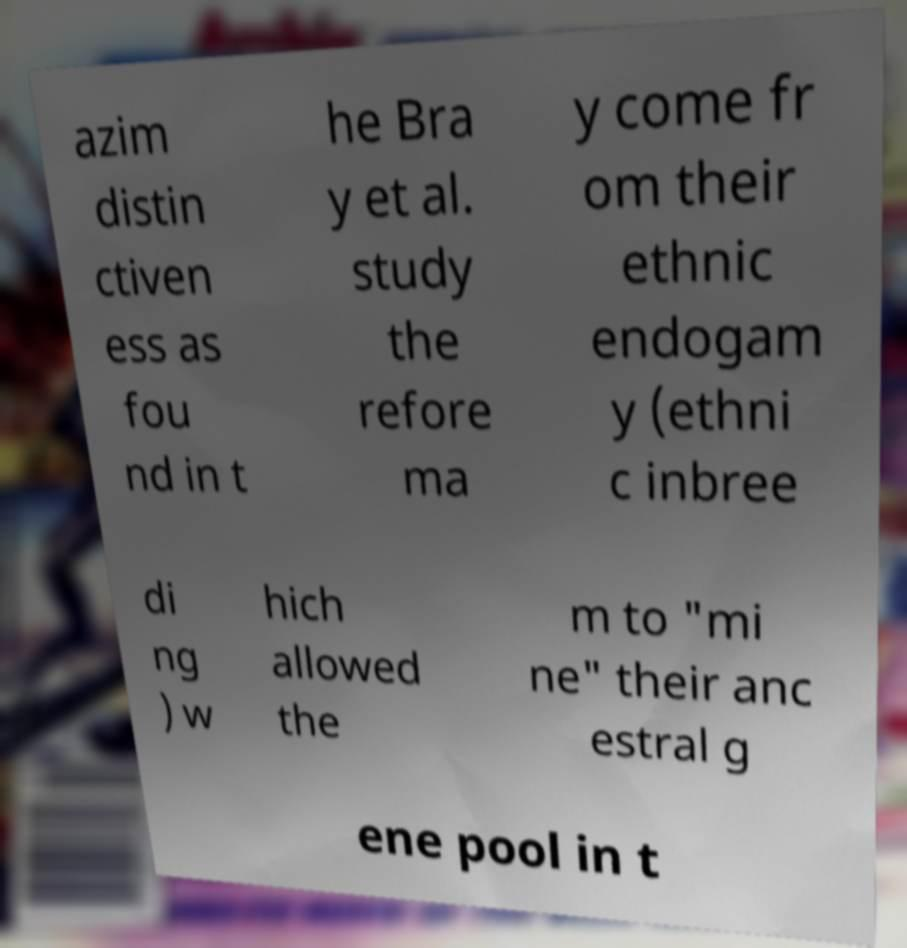I need the written content from this picture converted into text. Can you do that? azim distin ctiven ess as fou nd in t he Bra y et al. study the refore ma y come fr om their ethnic endogam y (ethni c inbree di ng ) w hich allowed the m to "mi ne" their anc estral g ene pool in t 